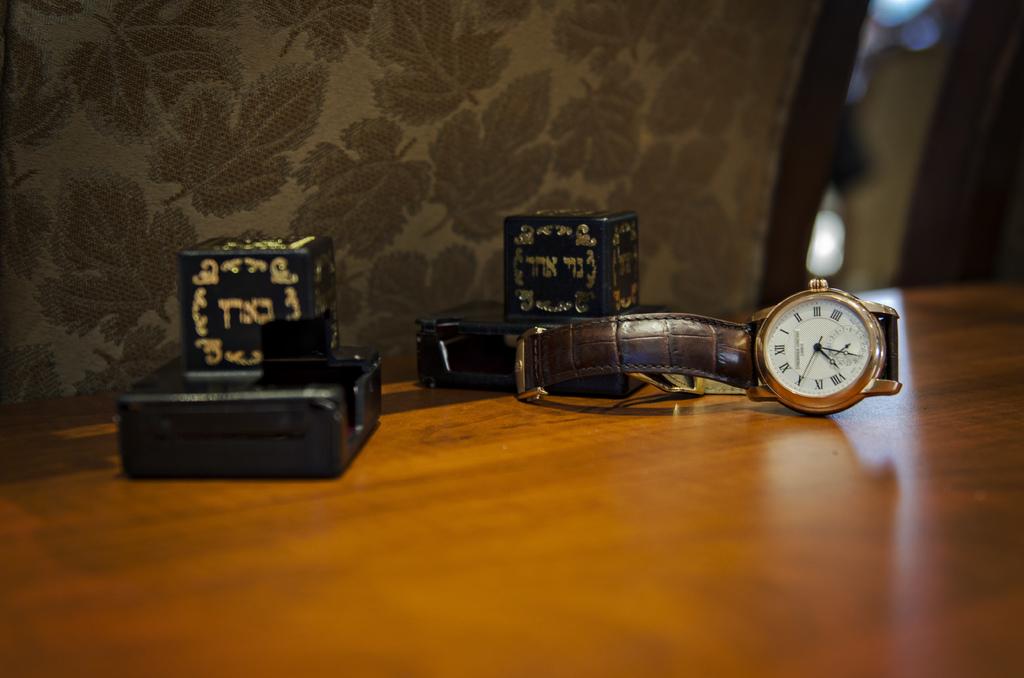What time does this watch say?
Give a very brief answer. 7:32. 